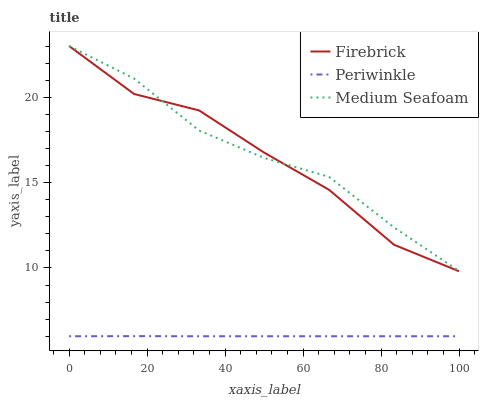Does Periwinkle have the minimum area under the curve?
Answer yes or no. Yes. Does Medium Seafoam have the maximum area under the curve?
Answer yes or no. Yes. Does Medium Seafoam have the minimum area under the curve?
Answer yes or no. No. Does Periwinkle have the maximum area under the curve?
Answer yes or no. No. Is Periwinkle the smoothest?
Answer yes or no. Yes. Is Firebrick the roughest?
Answer yes or no. Yes. Is Medium Seafoam the smoothest?
Answer yes or no. No. Is Medium Seafoam the roughest?
Answer yes or no. No. Does Periwinkle have the lowest value?
Answer yes or no. Yes. Does Medium Seafoam have the lowest value?
Answer yes or no. No. Does Medium Seafoam have the highest value?
Answer yes or no. Yes. Does Periwinkle have the highest value?
Answer yes or no. No. Is Periwinkle less than Medium Seafoam?
Answer yes or no. Yes. Is Firebrick greater than Periwinkle?
Answer yes or no. Yes. Does Firebrick intersect Medium Seafoam?
Answer yes or no. Yes. Is Firebrick less than Medium Seafoam?
Answer yes or no. No. Is Firebrick greater than Medium Seafoam?
Answer yes or no. No. Does Periwinkle intersect Medium Seafoam?
Answer yes or no. No. 